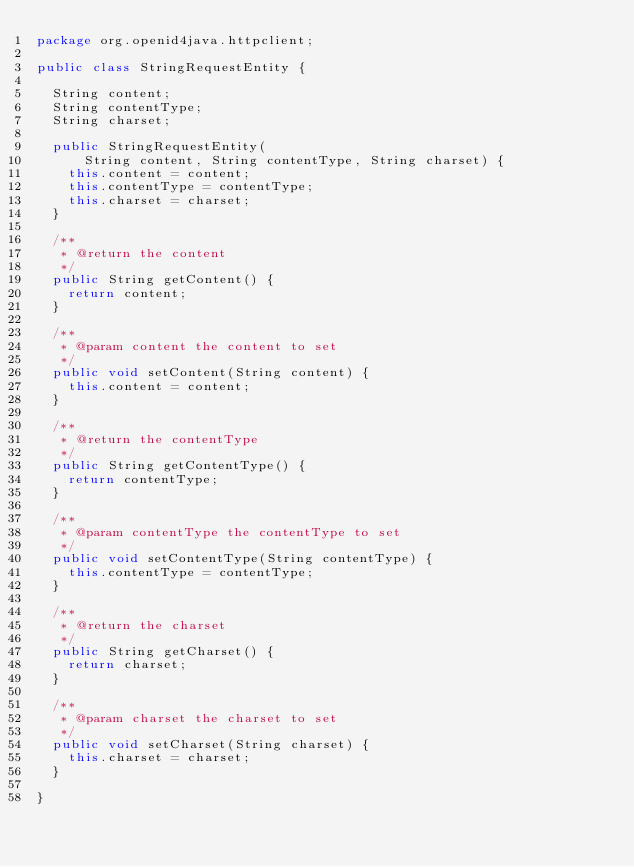Convert code to text. <code><loc_0><loc_0><loc_500><loc_500><_Java_>package org.openid4java.httpclient;

public class StringRequestEntity {

	String content;
	String contentType;
	String charset;
	
	public StringRequestEntity(
			String content, String contentType, String charset) {
		this.content = content;
		this.contentType = contentType;
		this.charset = charset;
	}

	/**
	 * @return the content
	 */
	public String getContent() {
		return content;
	}

	/**
	 * @param content the content to set
	 */
	public void setContent(String content) {
		this.content = content;
	}

	/**
	 * @return the contentType
	 */
	public String getContentType() {
		return contentType;
	}

	/**
	 * @param contentType the contentType to set
	 */
	public void setContentType(String contentType) {
		this.contentType = contentType;
	}

	/**
	 * @return the charset
	 */
	public String getCharset() {
		return charset;
	}

	/**
	 * @param charset the charset to set
	 */
	public void setCharset(String charset) {
		this.charset = charset;
	}

}
</code> 